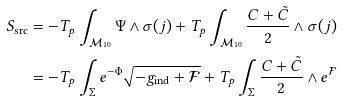Convert formula to latex. <formula><loc_0><loc_0><loc_500><loc_500>S _ { \text {src} } & = - T _ { p } \int _ { \mathcal { M } _ { 1 0 } } \Psi \wedge \sigma ( j ) + T _ { p } \int _ { \mathcal { M } _ { 1 0 } } \frac { C + \tilde { C } } { 2 } \wedge \sigma ( j ) \\ & = - T _ { p } \int _ { \Sigma } e ^ { - \Phi } \sqrt { - g _ { \text {ind} } + \mathcal { F } } + T _ { p } \int _ { \Sigma } \frac { C + \tilde { C } } { 2 } \wedge e ^ { \mathcal { F } }</formula> 